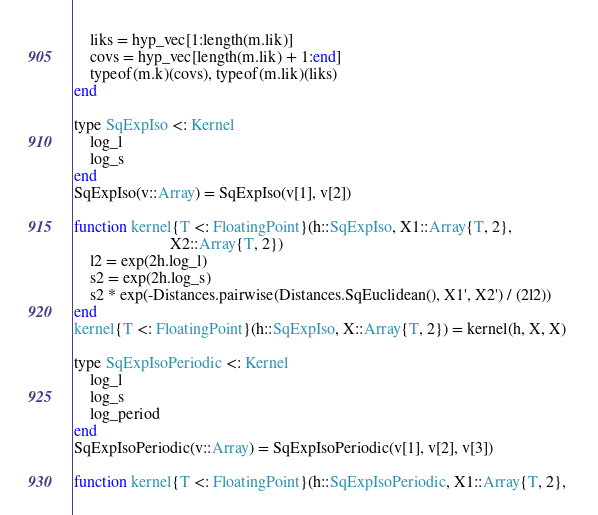Convert code to text. <code><loc_0><loc_0><loc_500><loc_500><_Julia_>	liks = hyp_vec[1:length(m.lik)]
	covs = hyp_vec[length(m.lik) + 1:end]
	typeof(m.k)(covs), typeof(m.lik)(liks)
end

type SqExpIso <: Kernel
	log_l
	log_s
end
SqExpIso(v::Array) = SqExpIso(v[1], v[2])

function kernel{T <: FloatingPoint}(h::SqExpIso, X1::Array{T, 2}, 
						X2::Array{T, 2}) 
	l2 = exp(2h.log_l)
	s2 = exp(2h.log_s)
	s2 * exp(-Distances.pairwise(Distances.SqEuclidean(), X1', X2') / (2l2))
end
kernel{T <: FloatingPoint}(h::SqExpIso, X::Array{T, 2}) = kernel(h, X, X)

type SqExpIsoPeriodic <: Kernel
	log_l
	log_s
	log_period
end
SqExpIsoPeriodic(v::Array) = SqExpIsoPeriodic(v[1], v[2], v[3])

function kernel{T <: FloatingPoint}(h::SqExpIsoPeriodic, X1::Array{T, 2}, </code> 